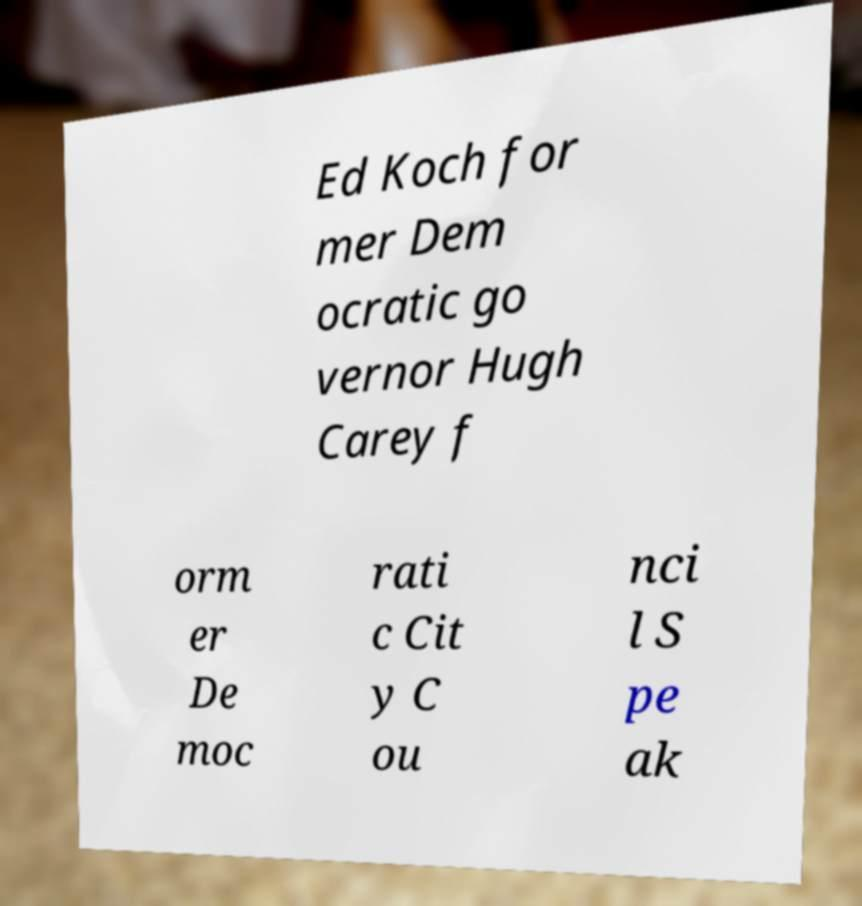There's text embedded in this image that I need extracted. Can you transcribe it verbatim? Ed Koch for mer Dem ocratic go vernor Hugh Carey f orm er De moc rati c Cit y C ou nci l S pe ak 